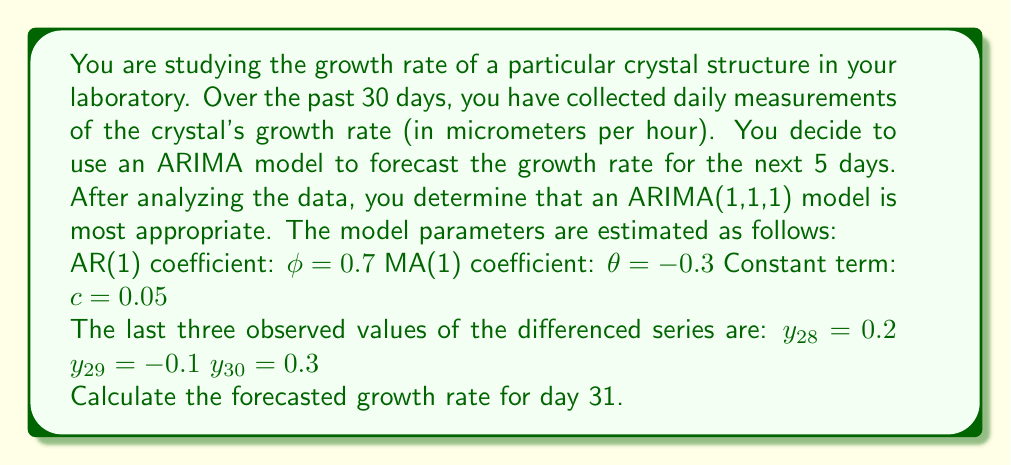What is the answer to this math problem? To solve this problem, we need to follow these steps:

1) Recall the general form of an ARIMA(1,1,1) model:

   $$(1 - \phi B)(1 - B)X_t = c + (1 + \theta B)\epsilon_t$$

   where $B$ is the backshift operator.

2) For forecasting, we can write this as:

   $$X_t - X_{t-1} = c + \phi(X_{t-1} - X_{t-2}) + \epsilon_t + \theta\epsilon_{t-1}$$

3) For one-step-ahead forecasting, we set $\epsilon_t = 0$ (as it's unknown) and use the most recent error term for $\epsilon_{t-1}$. We can calculate this as:

   $$\epsilon_{30} = y_{30} - (c + \phi y_{29})$$
   $$\epsilon_{30} = 0.3 - (0.05 + 0.7 * (-0.1)) = 0.28$$

4) Now we can forecast $y_{31}$:

   $$y_{31} = c + \phi y_{30} + \theta\epsilon_{30}$$
   $$y_{31} = 0.05 + 0.7 * 0.3 + (-0.3) * 0.28$$
   $$y_{31} = 0.05 + 0.21 - 0.084 = 0.176$$

5) Remember that $y_t$ represents the differenced series. To get the actual forecast for $X_{31}$, we need to "undo" the differencing:

   $$X_{31} = X_{30} + y_{31}$$

6) We don't know $X_{30}$ directly, but we can calculate it from the given information:

   $$X_{30} = X_{29} + y_{30}$$
   $$X_{29} = X_{28} + y_{29}$$
   $$X_{28} = x + y_{28}$$ (where $x$ is unknown)

   Substituting:
   $$X_{30} = x + y_{28} + y_{29} + y_{30} = x + 0.2 - 0.1 + 0.3 = x + 0.4$$

7) Therefore, our forecast for day 31 is:

   $$X_{31} = (x + 0.4) + 0.176 = x + 0.576$$

   The forecast has increased the growth rate by 0.576 micrometers per hour compared to day 28.
Answer: The forecasted growth rate for day 31 is 0.576 micrometers per hour higher than the growth rate on day 28. 